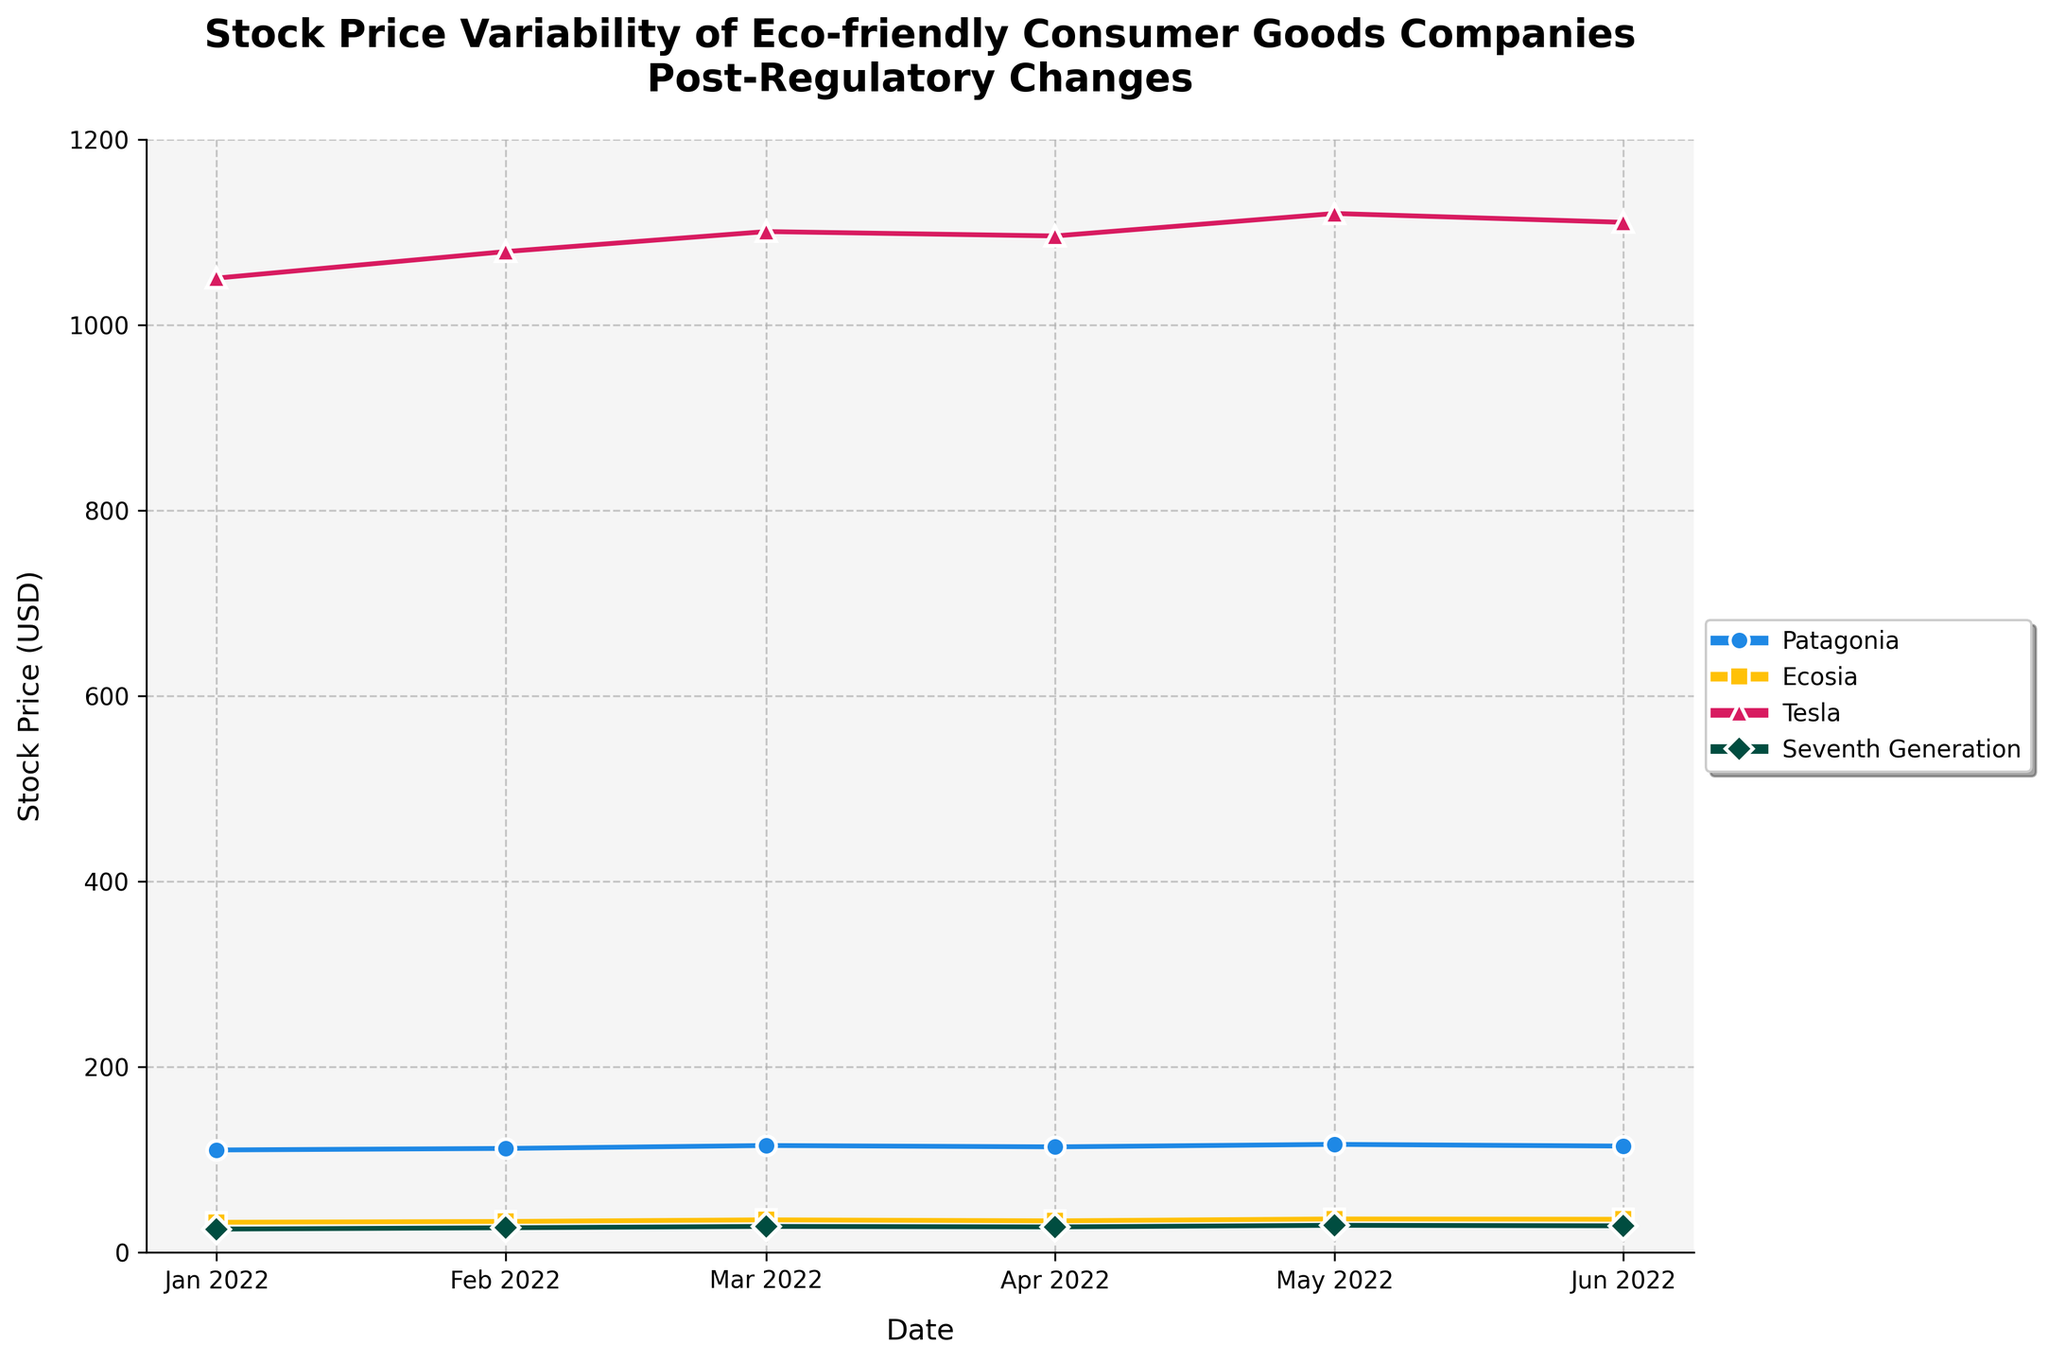Which company has the highest stock price in June 2022? Look at the stock prices for June 2022 and compare. Tesla has the highest stock price of $1110.45.
Answer: Tesla What is the overall trend in Patagonia's stock price from January 2022 to June 2022? Examine the line representing Patagonia's stock price. It generally increases from $110.45 in January to $114.65 in June, indicating a positive trend.
Answer: Increasing What is the difference between Ecosia's highest and lowest stock prices from January 2022 to June 2022? Identify the highest ($36.10 in May) and lowest ($32.50 in January) stock prices for Ecosia and calculate the difference: 36.10 - 32.50 = 3.60 USD.
Answer: 3.60 USD Which two companies showed the least variability in their stock prices from January 2022 to June 2022? Analyze the fluctuations in stock price lines for each company. Both Patagonia and Seventh Generation show relatively stable trends compared to Tesla and Ecosia.
Answer: Patagonia, Seventh Generation In which month did Tesla's stock price peak within the observed period? Review Tesla's stock prices across the months. The peak is in May 2022 at $1120.00.
Answer: May 2022 How many months did it take for Seventh Generation's stock price to reach above $28.00? Trace the stock price trend for Seventh Generation. It remained below $28.00 until April 2022, so it took 4 months (from January to April).
Answer: 4 months By how much did Patagonia's stock price increase from February 2022 to May 2022? Subtract Patagonia's February price ($112.10) from its May price ($116.50): 116.50 - 112.10 = 4.40 USD.
Answer: 4.40 USD Compare the average stock price of Tesla with that of Ecosia over the entire period shown. Calculate the average stock price for Tesla: (1050.30 + 1078.90 + 1100.50 + 1095.75 + 1120.00 + 1110.45) / 6 = 1092.15 USD. For Ecosia: (32.50 + 33.40 + 35.15 + 34.05 + 36.10 + 35.75) / 6 = 34.16 USD.
Answer: Tesla: 1092.15 USD, Ecosia: 34.16 USD Which company experienced the sharpest decline in stock price within a single month? Look at month-to-month changes for each company. Patagonia's stock price declined from $116.50 in May to $114.65 in June, a drop of $1.85. Compare with others. This drop is not the sharpest. Ecosia, Tesla, and Seventh Generation have positive or less significant drops. Tesla's drop from May to June is $9.55.
Answer: Tesla 